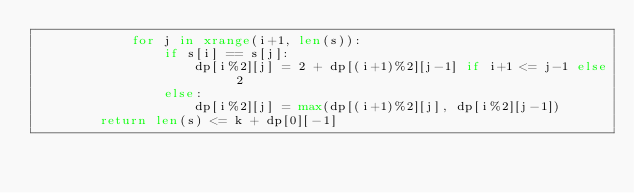<code> <loc_0><loc_0><loc_500><loc_500><_Python_>            for j in xrange(i+1, len(s)):
                if s[i] == s[j]:
                    dp[i%2][j] = 2 + dp[(i+1)%2][j-1] if i+1 <= j-1 else 2
                else:
                    dp[i%2][j] = max(dp[(i+1)%2][j], dp[i%2][j-1])
        return len(s) <= k + dp[0][-1]
</code> 